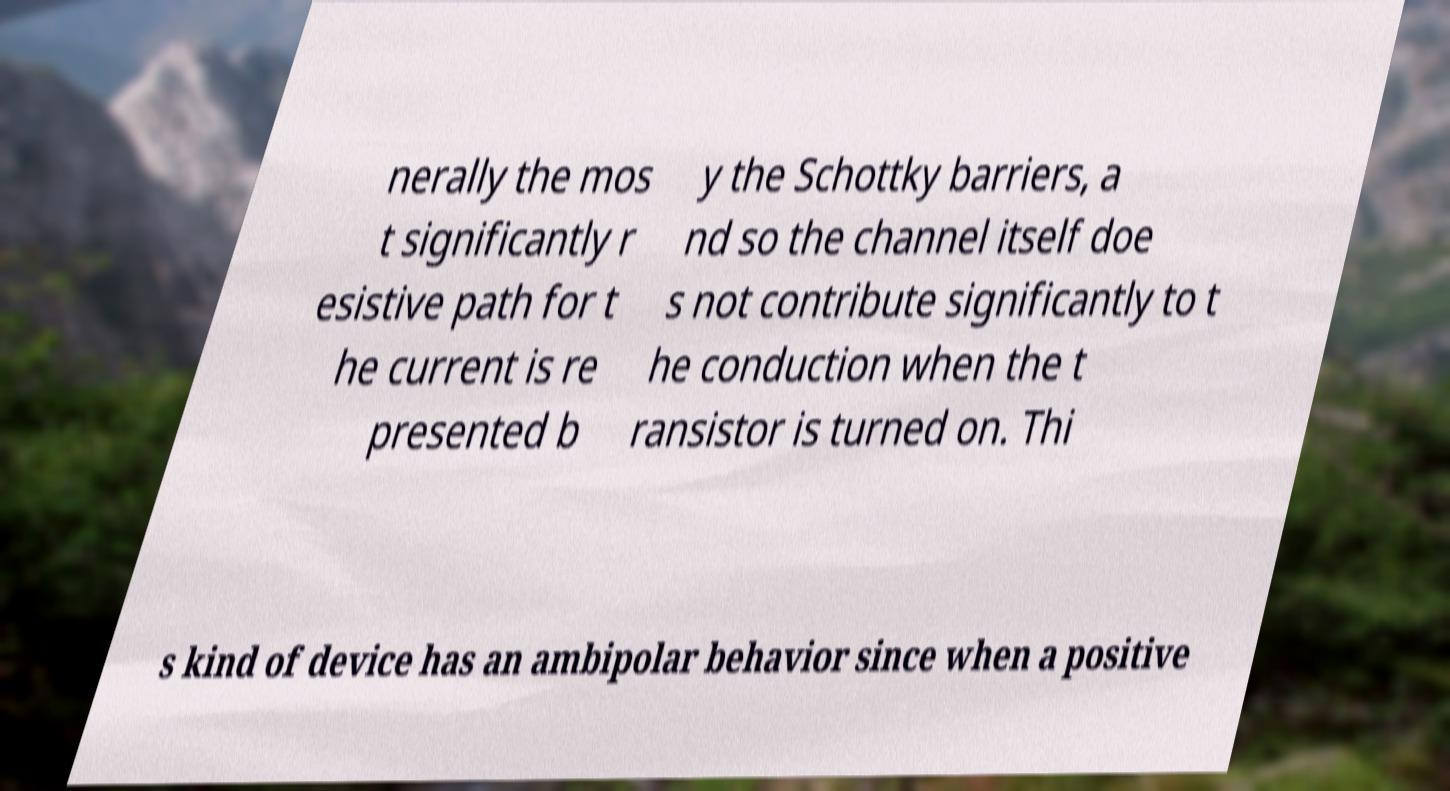Could you extract and type out the text from this image? nerally the mos t significantly r esistive path for t he current is re presented b y the Schottky barriers, a nd so the channel itself doe s not contribute significantly to t he conduction when the t ransistor is turned on. Thi s kind of device has an ambipolar behavior since when a positive 